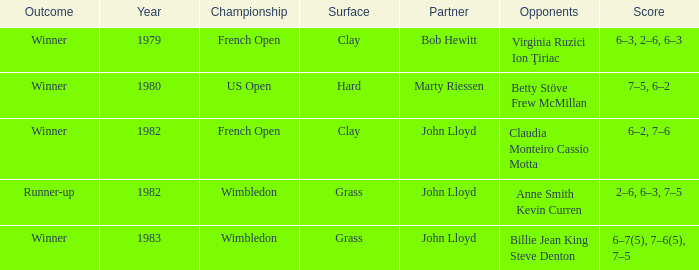Which adversaries resulted in a victor on a grass surface? Billie Jean King Steve Denton. 